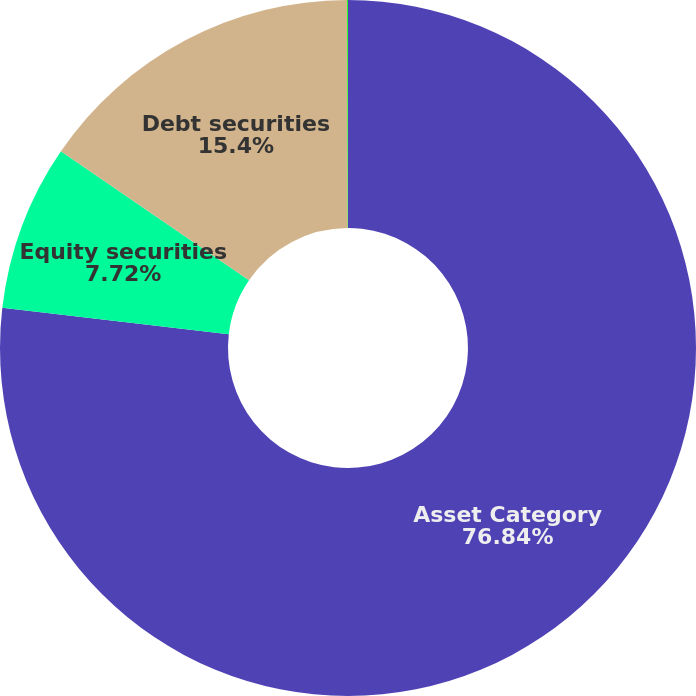<chart> <loc_0><loc_0><loc_500><loc_500><pie_chart><fcel>Asset Category<fcel>Equity securities<fcel>Debt securities<fcel>Other<nl><fcel>76.84%<fcel>7.72%<fcel>15.4%<fcel>0.04%<nl></chart> 